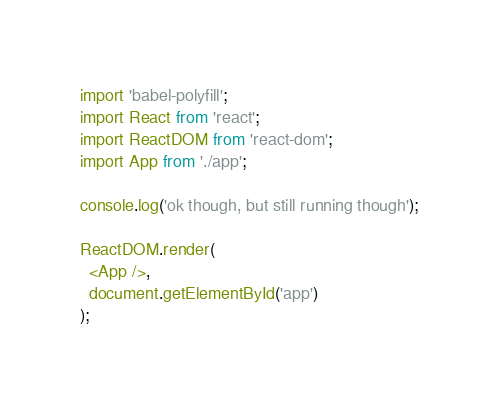<code> <loc_0><loc_0><loc_500><loc_500><_JavaScript_>import 'babel-polyfill';
import React from 'react';
import ReactDOM from 'react-dom';
import App from './app';

console.log('ok though, but still running though');

ReactDOM.render(
  <App />,
  document.getElementById('app')
);
</code> 